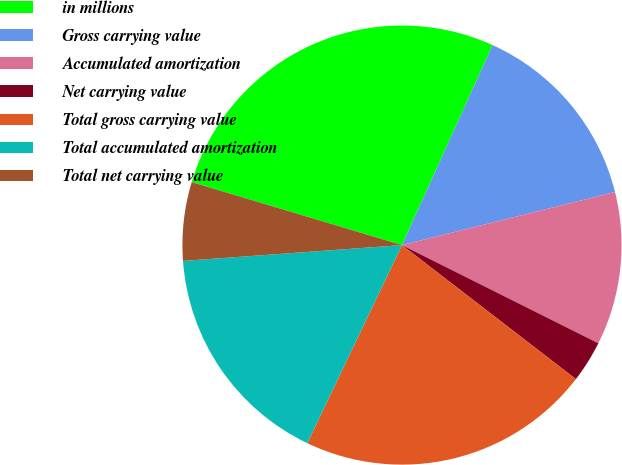<chart> <loc_0><loc_0><loc_500><loc_500><pie_chart><fcel>in millions<fcel>Gross carrying value<fcel>Accumulated amortization<fcel>Net carrying value<fcel>Total gross carrying value<fcel>Total accumulated amortization<fcel>Total net carrying value<nl><fcel>27.14%<fcel>14.34%<fcel>11.27%<fcel>3.07%<fcel>21.65%<fcel>16.75%<fcel>5.78%<nl></chart> 